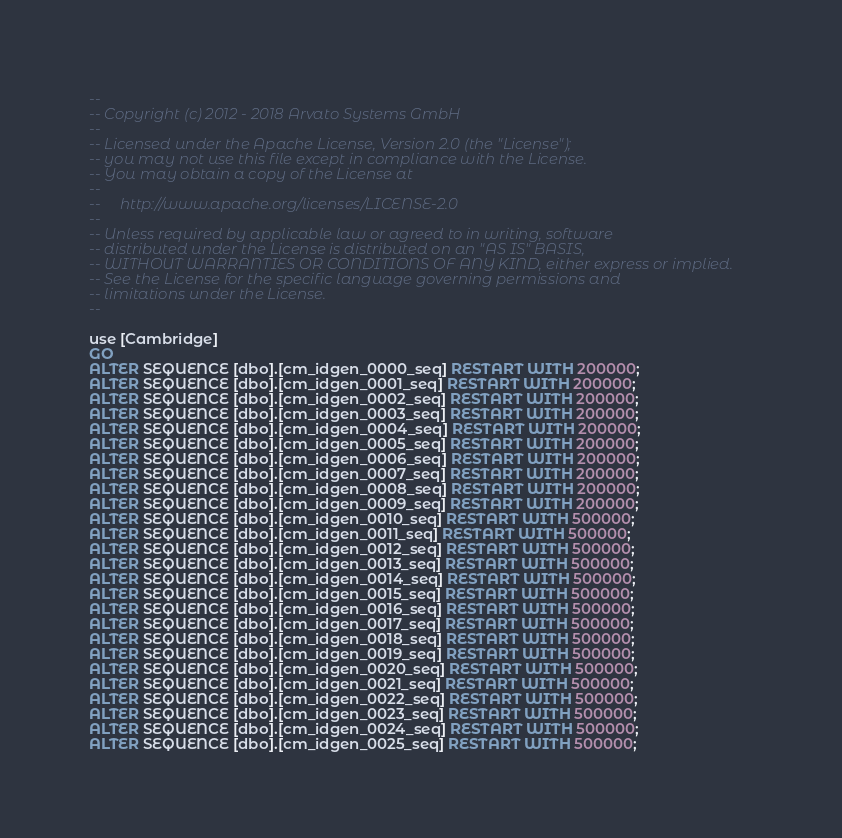Convert code to text. <code><loc_0><loc_0><loc_500><loc_500><_SQL_>--
-- Copyright (c) 2012 - 2018 Arvato Systems GmbH
--
-- Licensed under the Apache License, Version 2.0 (the "License");
-- you may not use this file except in compliance with the License.
-- You may obtain a copy of the License at
--
--     http://www.apache.org/licenses/LICENSE-2.0
--
-- Unless required by applicable law or agreed to in writing, software
-- distributed under the License is distributed on an "AS IS" BASIS,
-- WITHOUT WARRANTIES OR CONDITIONS OF ANY KIND, either express or implied.
-- See the License for the specific language governing permissions and
-- limitations under the License.
--

use [Cambridge]
GO
ALTER SEQUENCE [dbo].[cm_idgen_0000_seq] RESTART WITH 200000;
ALTER SEQUENCE [dbo].[cm_idgen_0001_seq] RESTART WITH 200000;
ALTER SEQUENCE [dbo].[cm_idgen_0002_seq] RESTART WITH 200000;
ALTER SEQUENCE [dbo].[cm_idgen_0003_seq] RESTART WITH 200000;
ALTER SEQUENCE [dbo].[cm_idgen_0004_seq] RESTART WITH 200000;
ALTER SEQUENCE [dbo].[cm_idgen_0005_seq] RESTART WITH 200000;
ALTER SEQUENCE [dbo].[cm_idgen_0006_seq] RESTART WITH 200000;
ALTER SEQUENCE [dbo].[cm_idgen_0007_seq] RESTART WITH 200000;
ALTER SEQUENCE [dbo].[cm_idgen_0008_seq] RESTART WITH 200000;
ALTER SEQUENCE [dbo].[cm_idgen_0009_seq] RESTART WITH 200000;
ALTER SEQUENCE [dbo].[cm_idgen_0010_seq] RESTART WITH 500000;
ALTER SEQUENCE [dbo].[cm_idgen_0011_seq] RESTART WITH 500000;
ALTER SEQUENCE [dbo].[cm_idgen_0012_seq] RESTART WITH 500000;
ALTER SEQUENCE [dbo].[cm_idgen_0013_seq] RESTART WITH 500000;
ALTER SEQUENCE [dbo].[cm_idgen_0014_seq] RESTART WITH 500000;
ALTER SEQUENCE [dbo].[cm_idgen_0015_seq] RESTART WITH 500000;
ALTER SEQUENCE [dbo].[cm_idgen_0016_seq] RESTART WITH 500000;
ALTER SEQUENCE [dbo].[cm_idgen_0017_seq] RESTART WITH 500000;
ALTER SEQUENCE [dbo].[cm_idgen_0018_seq] RESTART WITH 500000;
ALTER SEQUENCE [dbo].[cm_idgen_0019_seq] RESTART WITH 500000;
ALTER SEQUENCE [dbo].[cm_idgen_0020_seq] RESTART WITH 500000;
ALTER SEQUENCE [dbo].[cm_idgen_0021_seq] RESTART WITH 500000;
ALTER SEQUENCE [dbo].[cm_idgen_0022_seq] RESTART WITH 500000;
ALTER SEQUENCE [dbo].[cm_idgen_0023_seq] RESTART WITH 500000;
ALTER SEQUENCE [dbo].[cm_idgen_0024_seq] RESTART WITH 500000;
ALTER SEQUENCE [dbo].[cm_idgen_0025_seq] RESTART WITH 500000;</code> 